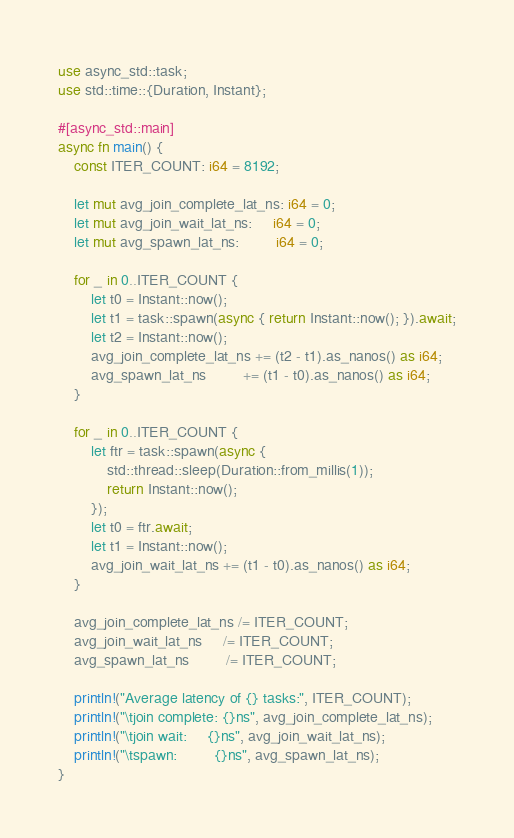<code> <loc_0><loc_0><loc_500><loc_500><_Rust_>use async_std::task;
use std::time::{Duration, Instant};

#[async_std::main]
async fn main() {
	const ITER_COUNT: i64 = 8192;

	let mut avg_join_complete_lat_ns: i64 = 0;
	let mut avg_join_wait_lat_ns:     i64 = 0;
	let mut avg_spawn_lat_ns:         i64 = 0;

	for _ in 0..ITER_COUNT {
		let t0 = Instant::now();
		let t1 = task::spawn(async { return Instant::now(); }).await;
		let t2 = Instant::now();
		avg_join_complete_lat_ns += (t2 - t1).as_nanos() as i64;
		avg_spawn_lat_ns         += (t1 - t0).as_nanos() as i64;
	}

	for _ in 0..ITER_COUNT {
		let ftr = task::spawn(async {
			std::thread::sleep(Duration::from_millis(1));
			return Instant::now();
		});
		let t0 = ftr.await;
		let t1 = Instant::now();
		avg_join_wait_lat_ns += (t1 - t0).as_nanos() as i64;
	}

	avg_join_complete_lat_ns /= ITER_COUNT;
	avg_join_wait_lat_ns     /= ITER_COUNT;
	avg_spawn_lat_ns         /= ITER_COUNT;

	println!("Average latency of {} tasks:", ITER_COUNT);
	println!("\tjoin complete: {}ns", avg_join_complete_lat_ns);
	println!("\tjoin wait:     {}ns", avg_join_wait_lat_ns);
	println!("\tspawn:         {}ns", avg_spawn_lat_ns);
}
</code> 